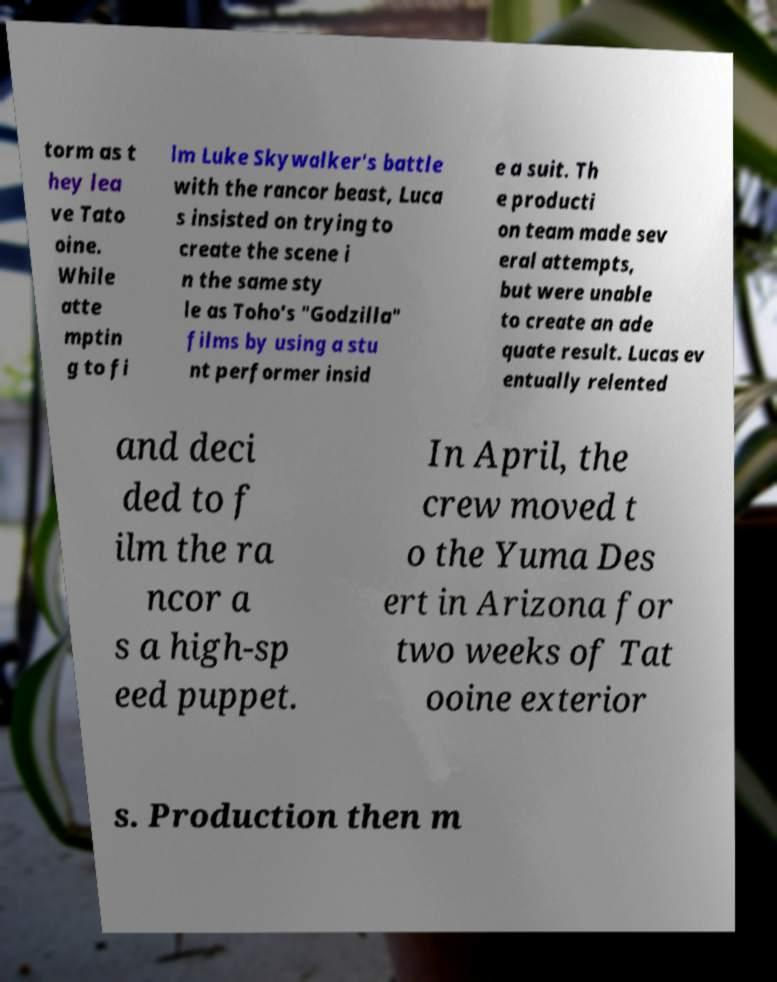Please read and relay the text visible in this image. What does it say? torm as t hey lea ve Tato oine. While atte mptin g to fi lm Luke Skywalker's battle with the rancor beast, Luca s insisted on trying to create the scene i n the same sty le as Toho's "Godzilla" films by using a stu nt performer insid e a suit. Th e producti on team made sev eral attempts, but were unable to create an ade quate result. Lucas ev entually relented and deci ded to f ilm the ra ncor a s a high-sp eed puppet. In April, the crew moved t o the Yuma Des ert in Arizona for two weeks of Tat ooine exterior s. Production then m 